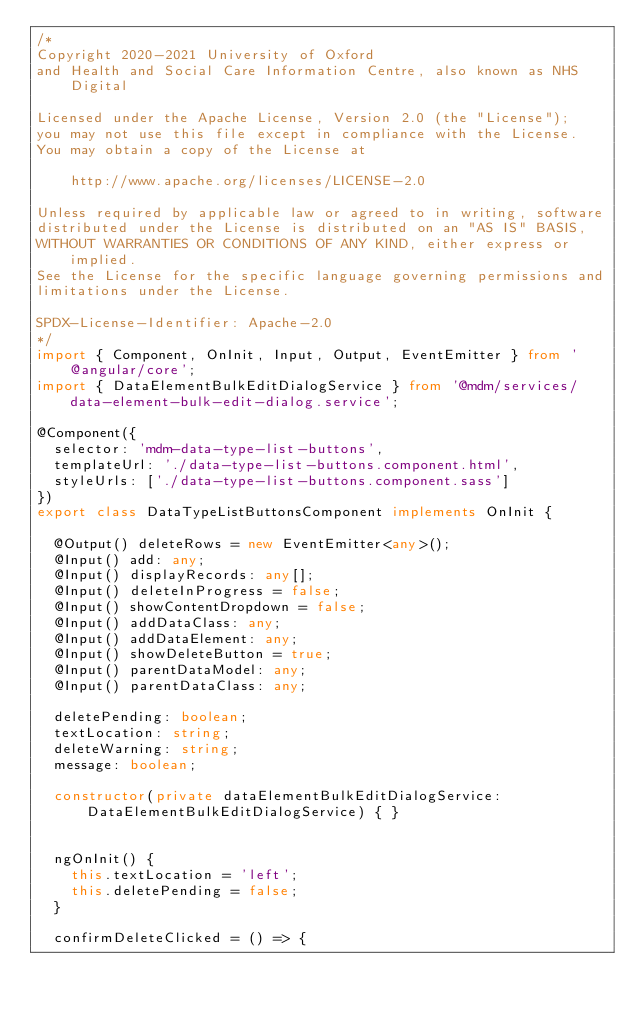Convert code to text. <code><loc_0><loc_0><loc_500><loc_500><_TypeScript_>/*
Copyright 2020-2021 University of Oxford
and Health and Social Care Information Centre, also known as NHS Digital

Licensed under the Apache License, Version 2.0 (the "License");
you may not use this file except in compliance with the License.
You may obtain a copy of the License at

    http://www.apache.org/licenses/LICENSE-2.0

Unless required by applicable law or agreed to in writing, software
distributed under the License is distributed on an "AS IS" BASIS,
WITHOUT WARRANTIES OR CONDITIONS OF ANY KIND, either express or implied.
See the License for the specific language governing permissions and
limitations under the License.

SPDX-License-Identifier: Apache-2.0
*/
import { Component, OnInit, Input, Output, EventEmitter } from '@angular/core';
import { DataElementBulkEditDialogService } from '@mdm/services/data-element-bulk-edit-dialog.service';

@Component({
  selector: 'mdm-data-type-list-buttons',
  templateUrl: './data-type-list-buttons.component.html',
  styleUrls: ['./data-type-list-buttons.component.sass']
})
export class DataTypeListButtonsComponent implements OnInit {

  @Output() deleteRows = new EventEmitter<any>();
  @Input() add: any;
  @Input() displayRecords: any[];
  @Input() deleteInProgress = false;
  @Input() showContentDropdown = false;
  @Input() addDataClass: any;
  @Input() addDataElement: any;
  @Input() showDeleteButton = true;
  @Input() parentDataModel: any;
  @Input() parentDataClass: any;

  deletePending: boolean;
  textLocation: string;
  deleteWarning: string;
  message: boolean;

  constructor(private dataElementBulkEditDialogService: DataElementBulkEditDialogService) { }


  ngOnInit() {
    this.textLocation = 'left';
    this.deletePending = false;
  }

  confirmDeleteClicked = () => {</code> 